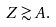<formula> <loc_0><loc_0><loc_500><loc_500>Z \gtrsim A .</formula> 